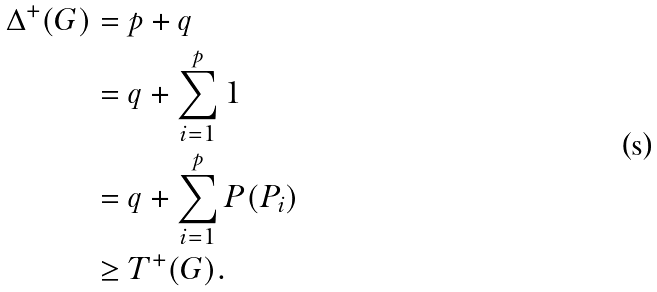<formula> <loc_0><loc_0><loc_500><loc_500>\Delta ^ { + } ( G ) & = p + q \\ & = q + \sum _ { i = 1 } ^ { p } 1 \\ & = q + \sum _ { i = 1 } ^ { p } P ( P _ { i } ) \\ & \geq T ^ { + } ( G ) .</formula> 